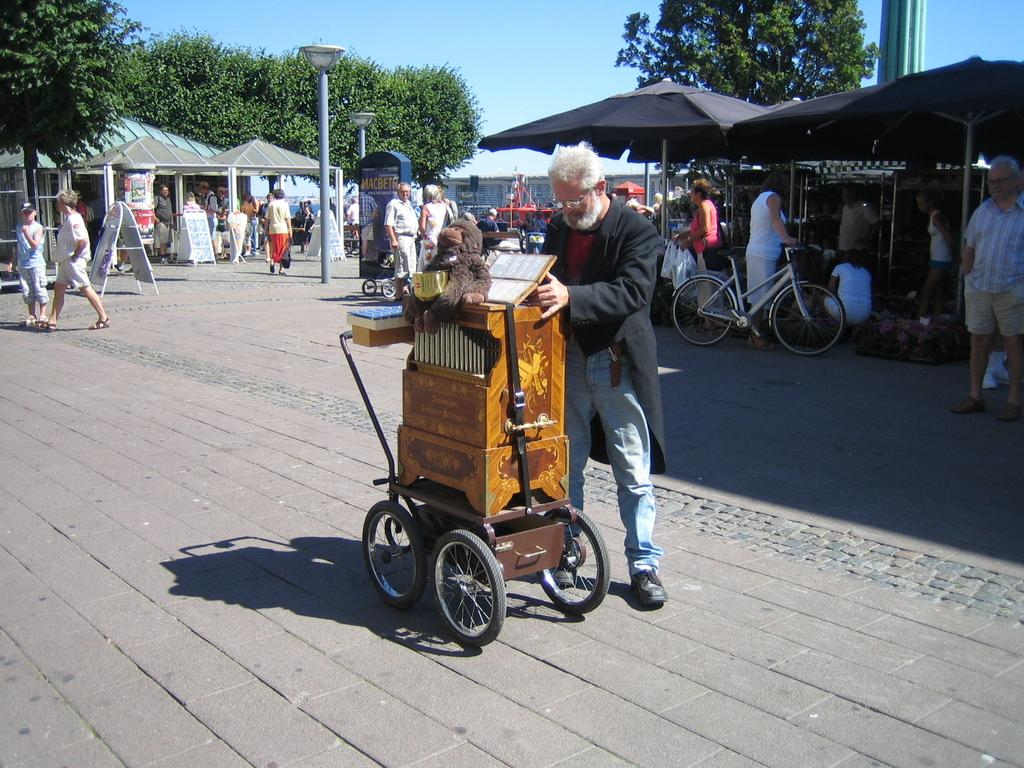What is the main subject of the image? The main subject of the image is a man. What is the man holding in the image? The man is holding a wooden object. Can you describe the background of the image? There are people, poles, and trees in the background of the image. What is the condition of the sky in the image? The sky is clear in the image. What type of station can be seen in the image? There is no station present in the image. What kind of quilt is being used by the man in the image? The man is not using a quilt in the image; he is holding a wooden object. 